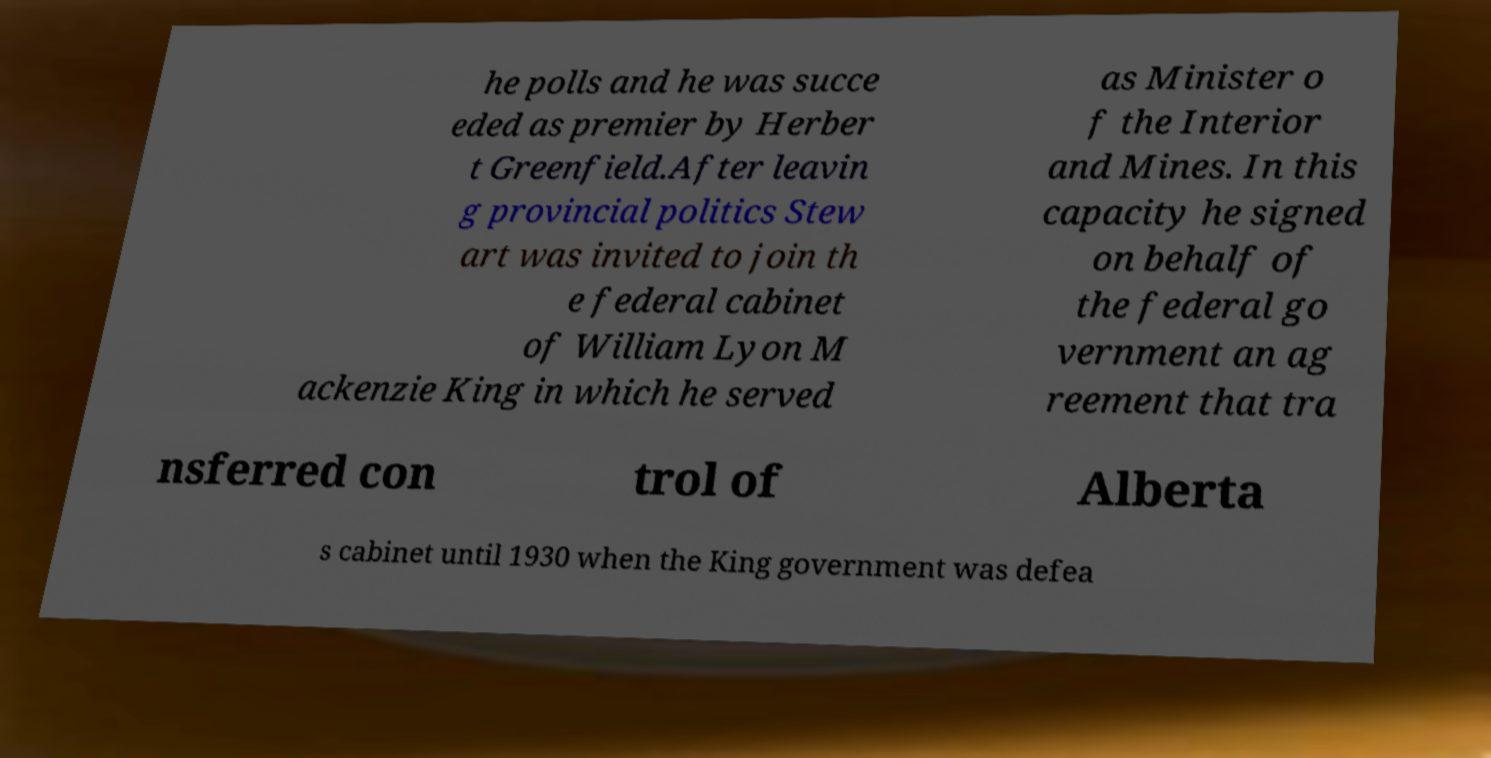Please read and relay the text visible in this image. What does it say? he polls and he was succe eded as premier by Herber t Greenfield.After leavin g provincial politics Stew art was invited to join th e federal cabinet of William Lyon M ackenzie King in which he served as Minister o f the Interior and Mines. In this capacity he signed on behalf of the federal go vernment an ag reement that tra nsferred con trol of Alberta s cabinet until 1930 when the King government was defea 